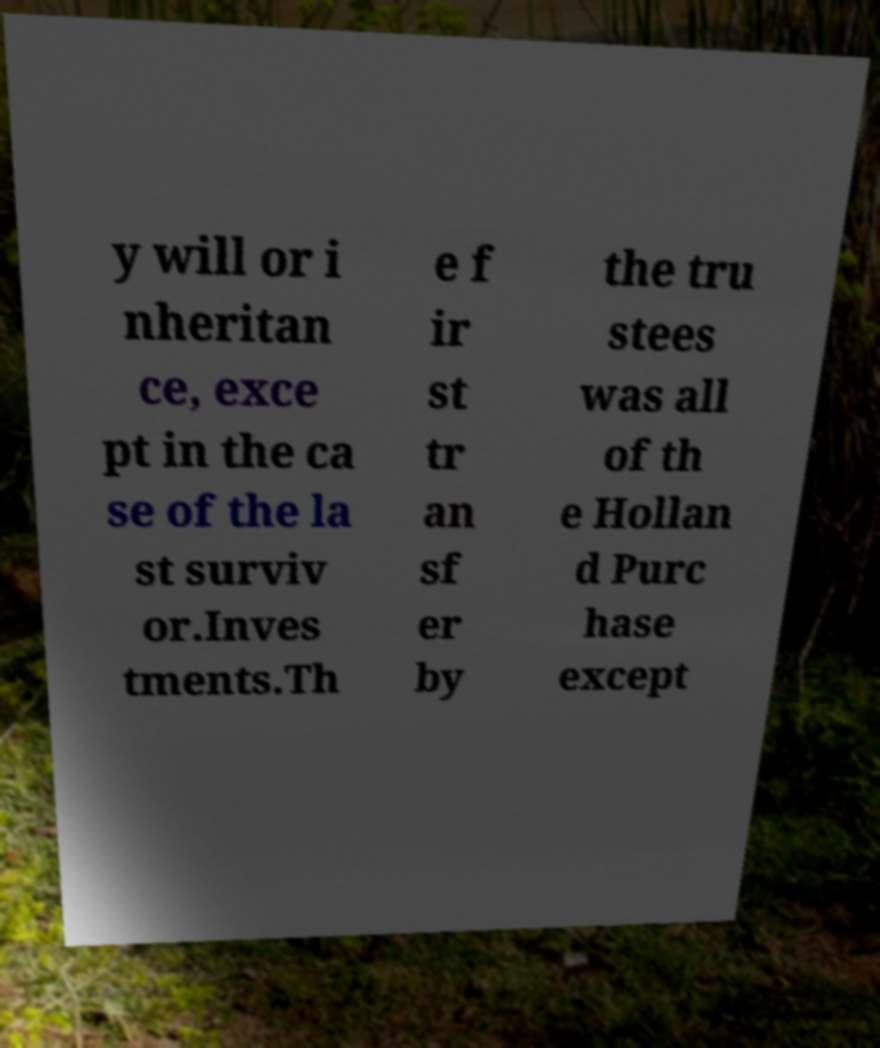There's text embedded in this image that I need extracted. Can you transcribe it verbatim? y will or i nheritan ce, exce pt in the ca se of the la st surviv or.Inves tments.Th e f ir st tr an sf er by the tru stees was all of th e Hollan d Purc hase except 